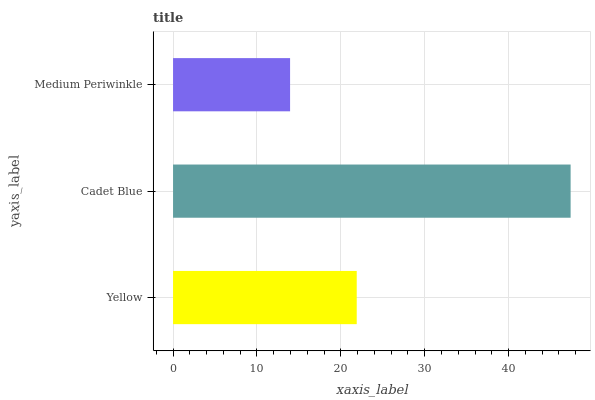Is Medium Periwinkle the minimum?
Answer yes or no. Yes. Is Cadet Blue the maximum?
Answer yes or no. Yes. Is Cadet Blue the minimum?
Answer yes or no. No. Is Medium Periwinkle the maximum?
Answer yes or no. No. Is Cadet Blue greater than Medium Periwinkle?
Answer yes or no. Yes. Is Medium Periwinkle less than Cadet Blue?
Answer yes or no. Yes. Is Medium Periwinkle greater than Cadet Blue?
Answer yes or no. No. Is Cadet Blue less than Medium Periwinkle?
Answer yes or no. No. Is Yellow the high median?
Answer yes or no. Yes. Is Yellow the low median?
Answer yes or no. Yes. Is Cadet Blue the high median?
Answer yes or no. No. Is Medium Periwinkle the low median?
Answer yes or no. No. 